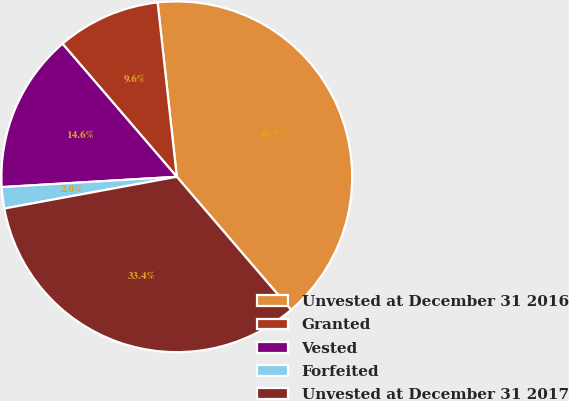Convert chart to OTSL. <chart><loc_0><loc_0><loc_500><loc_500><pie_chart><fcel>Unvested at December 31 2016<fcel>Granted<fcel>Vested<fcel>Forfeited<fcel>Unvested at December 31 2017<nl><fcel>40.45%<fcel>9.55%<fcel>14.64%<fcel>1.96%<fcel>33.39%<nl></chart> 